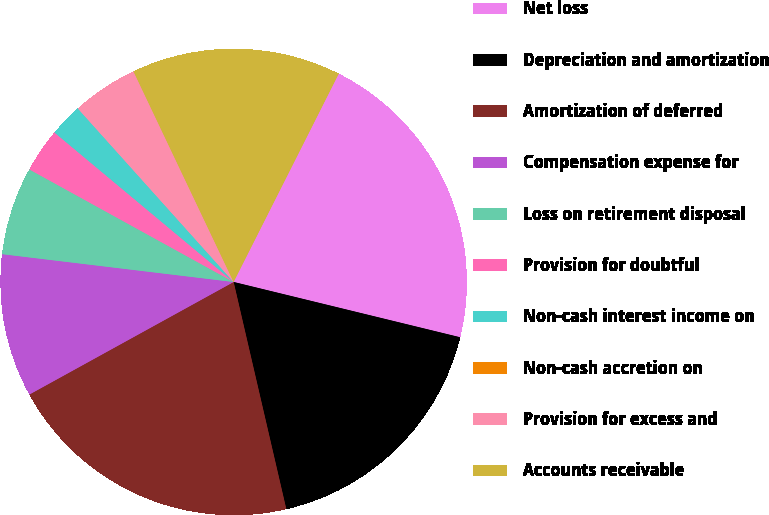Convert chart. <chart><loc_0><loc_0><loc_500><loc_500><pie_chart><fcel>Net loss<fcel>Depreciation and amortization<fcel>Amortization of deferred<fcel>Compensation expense for<fcel>Loss on retirement disposal<fcel>Provision for doubtful<fcel>Non-cash interest income on<fcel>Non-cash accretion on<fcel>Provision for excess and<fcel>Accounts receivable<nl><fcel>21.37%<fcel>17.56%<fcel>20.61%<fcel>9.92%<fcel>6.11%<fcel>3.05%<fcel>2.29%<fcel>0.0%<fcel>4.58%<fcel>14.5%<nl></chart> 